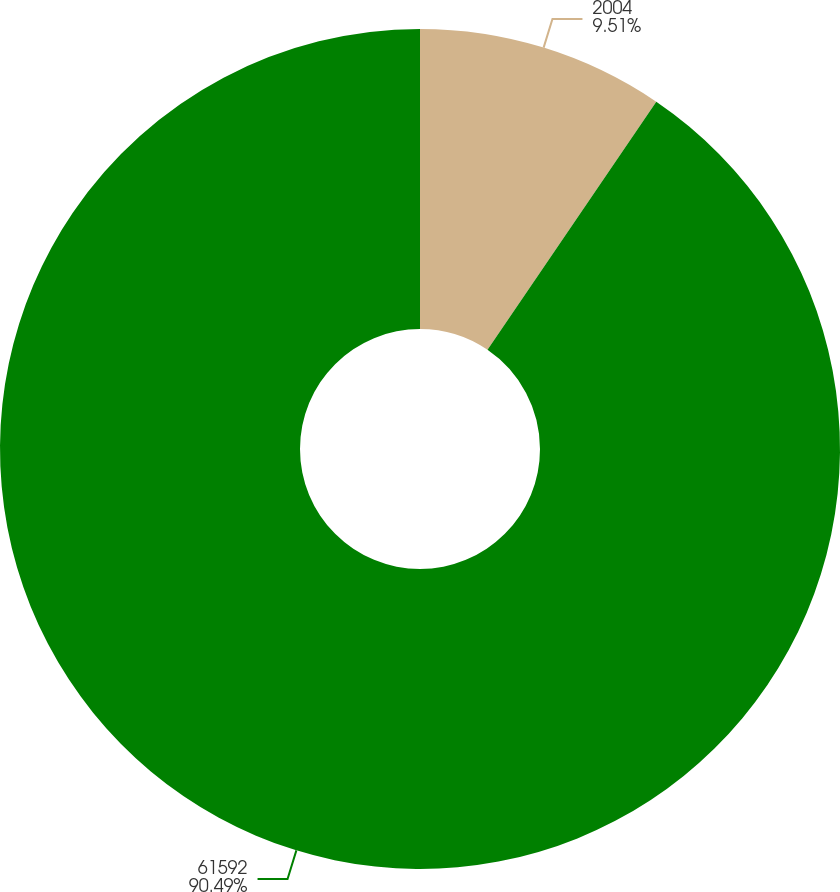Convert chart to OTSL. <chart><loc_0><loc_0><loc_500><loc_500><pie_chart><fcel>2004<fcel>61592<nl><fcel>9.51%<fcel>90.49%<nl></chart> 